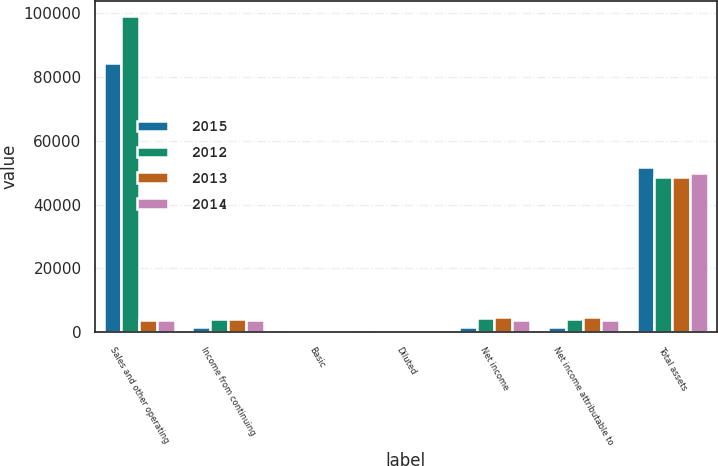<chart> <loc_0><loc_0><loc_500><loc_500><stacked_bar_chart><ecel><fcel>Sales and other operating<fcel>Income from continuing<fcel>Basic<fcel>Diluted<fcel>Net income<fcel>Net income attributable to<fcel>Total assets<nl><fcel>2015<fcel>84279<fcel>1555<fcel>2.94<fcel>2.92<fcel>1644<fcel>1555<fcel>51653<nl><fcel>2012<fcel>98975<fcel>4227<fcel>7.78<fcel>7.73<fcel>4280<fcel>4227<fcel>48580<nl><fcel>2013<fcel>3734.5<fcel>4056<fcel>7.15<fcel>7.1<fcel>4797<fcel>4762<fcel>48692<nl><fcel>2014<fcel>3734.5<fcel>3665<fcel>5.97<fcel>5.92<fcel>3743<fcel>3726<fcel>49769<nl></chart> 